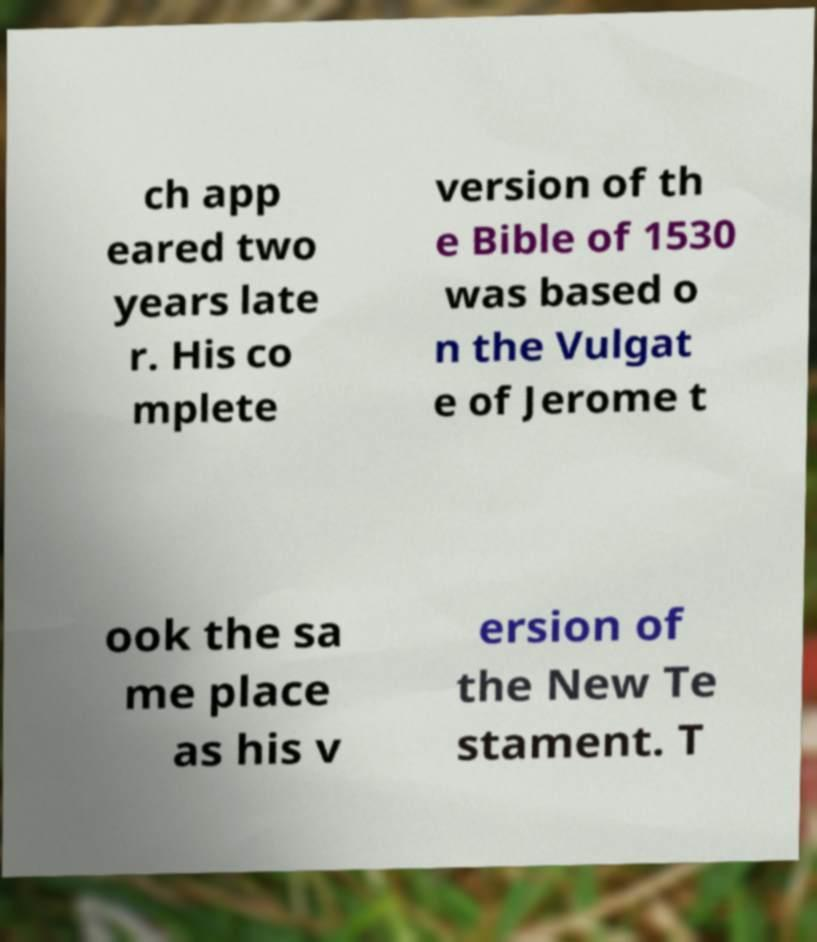For documentation purposes, I need the text within this image transcribed. Could you provide that? ch app eared two years late r. His co mplete version of th e Bible of 1530 was based o n the Vulgat e of Jerome t ook the sa me place as his v ersion of the New Te stament. T 